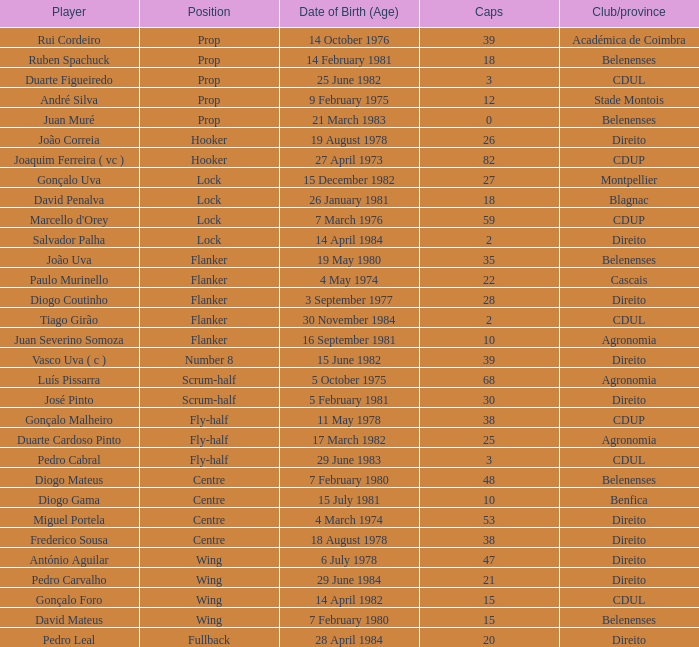How many caps have a Position of prop, and a Player of rui cordeiro? 1.0. 